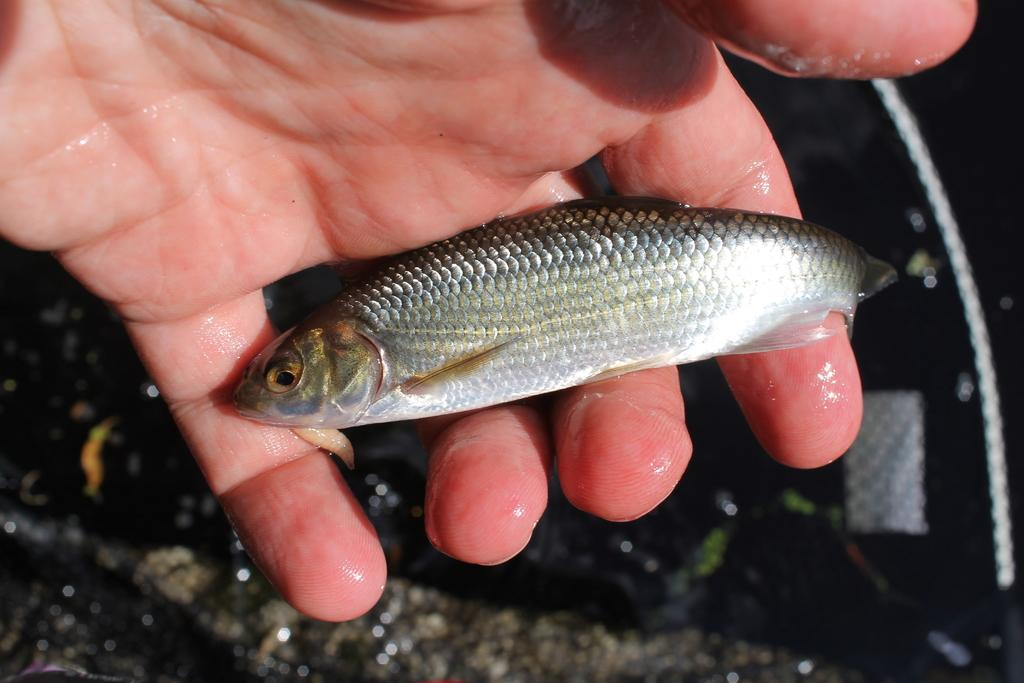What is the main subject of the image? The main subject of the image is a fish. Can you describe the location of the fish in the image? The fish is in the hand of a person. What type of rice is being used to create the board in the image? There is no rice or board present in the image; it only shows a fish in the hand of a person. 